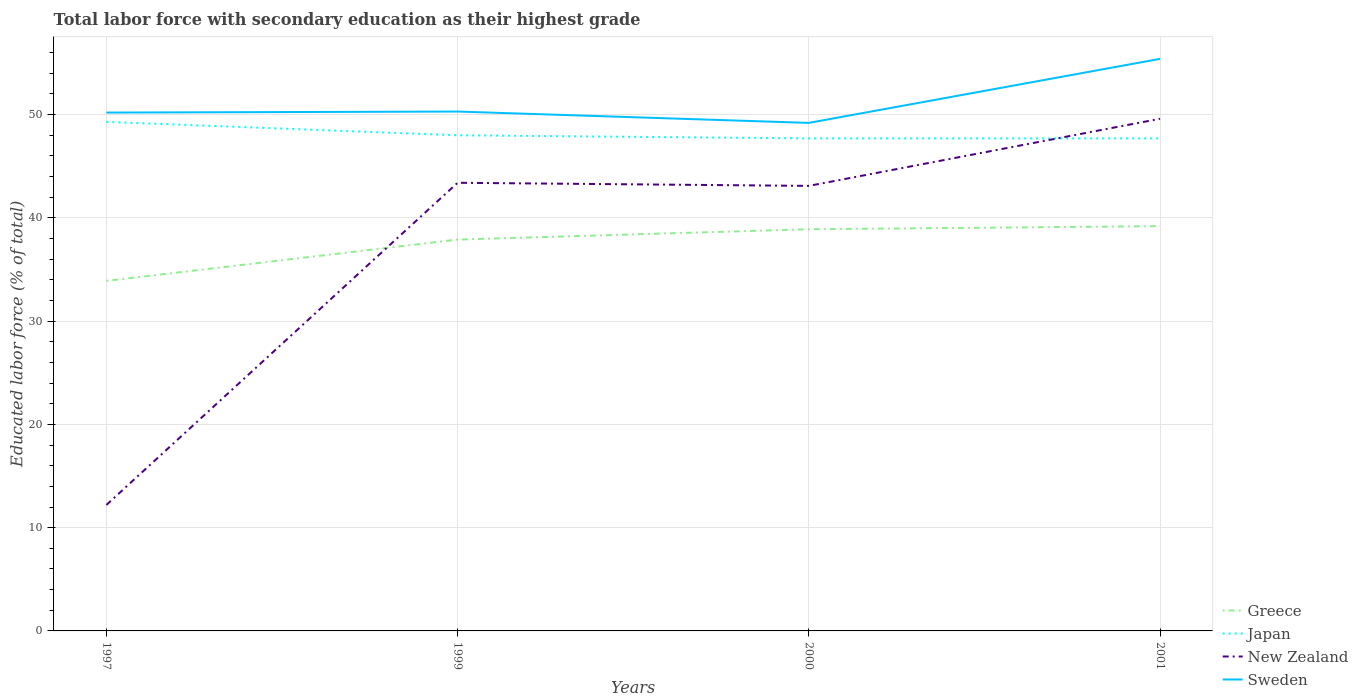How many different coloured lines are there?
Keep it short and to the point. 4. Does the line corresponding to Greece intersect with the line corresponding to Japan?
Offer a very short reply. No. Across all years, what is the maximum percentage of total labor force with primary education in Sweden?
Give a very brief answer. 49.2. In which year was the percentage of total labor force with primary education in Japan maximum?
Offer a very short reply. 2000. What is the total percentage of total labor force with primary education in New Zealand in the graph?
Your answer should be compact. 0.3. What is the difference between the highest and the second highest percentage of total labor force with primary education in Japan?
Keep it short and to the point. 1.6. What is the difference between the highest and the lowest percentage of total labor force with primary education in Japan?
Keep it short and to the point. 1. How many years are there in the graph?
Make the answer very short. 4. Where does the legend appear in the graph?
Your answer should be compact. Bottom right. How many legend labels are there?
Provide a short and direct response. 4. What is the title of the graph?
Your response must be concise. Total labor force with secondary education as their highest grade. What is the label or title of the Y-axis?
Keep it short and to the point. Educated labor force (% of total). What is the Educated labor force (% of total) of Greece in 1997?
Give a very brief answer. 33.9. What is the Educated labor force (% of total) of Japan in 1997?
Make the answer very short. 49.3. What is the Educated labor force (% of total) of New Zealand in 1997?
Give a very brief answer. 12.2. What is the Educated labor force (% of total) of Sweden in 1997?
Provide a short and direct response. 50.2. What is the Educated labor force (% of total) in Greece in 1999?
Offer a terse response. 37.9. What is the Educated labor force (% of total) in Japan in 1999?
Your answer should be compact. 48. What is the Educated labor force (% of total) in New Zealand in 1999?
Ensure brevity in your answer.  43.4. What is the Educated labor force (% of total) in Sweden in 1999?
Give a very brief answer. 50.3. What is the Educated labor force (% of total) in Greece in 2000?
Your response must be concise. 38.9. What is the Educated labor force (% of total) of Japan in 2000?
Your answer should be very brief. 47.7. What is the Educated labor force (% of total) in New Zealand in 2000?
Offer a very short reply. 43.1. What is the Educated labor force (% of total) of Sweden in 2000?
Offer a terse response. 49.2. What is the Educated labor force (% of total) in Greece in 2001?
Provide a succinct answer. 39.2. What is the Educated labor force (% of total) of Japan in 2001?
Give a very brief answer. 47.7. What is the Educated labor force (% of total) in New Zealand in 2001?
Keep it short and to the point. 49.6. What is the Educated labor force (% of total) of Sweden in 2001?
Ensure brevity in your answer.  55.4. Across all years, what is the maximum Educated labor force (% of total) in Greece?
Provide a short and direct response. 39.2. Across all years, what is the maximum Educated labor force (% of total) in Japan?
Make the answer very short. 49.3. Across all years, what is the maximum Educated labor force (% of total) of New Zealand?
Offer a terse response. 49.6. Across all years, what is the maximum Educated labor force (% of total) of Sweden?
Offer a terse response. 55.4. Across all years, what is the minimum Educated labor force (% of total) of Greece?
Keep it short and to the point. 33.9. Across all years, what is the minimum Educated labor force (% of total) of Japan?
Your answer should be very brief. 47.7. Across all years, what is the minimum Educated labor force (% of total) of New Zealand?
Your answer should be very brief. 12.2. Across all years, what is the minimum Educated labor force (% of total) of Sweden?
Provide a succinct answer. 49.2. What is the total Educated labor force (% of total) in Greece in the graph?
Provide a succinct answer. 149.9. What is the total Educated labor force (% of total) of Japan in the graph?
Your answer should be compact. 192.7. What is the total Educated labor force (% of total) of New Zealand in the graph?
Offer a terse response. 148.3. What is the total Educated labor force (% of total) in Sweden in the graph?
Offer a terse response. 205.1. What is the difference between the Educated labor force (% of total) in New Zealand in 1997 and that in 1999?
Make the answer very short. -31.2. What is the difference between the Educated labor force (% of total) in Sweden in 1997 and that in 1999?
Keep it short and to the point. -0.1. What is the difference between the Educated labor force (% of total) in Greece in 1997 and that in 2000?
Keep it short and to the point. -5. What is the difference between the Educated labor force (% of total) of New Zealand in 1997 and that in 2000?
Ensure brevity in your answer.  -30.9. What is the difference between the Educated labor force (% of total) of Sweden in 1997 and that in 2000?
Offer a very short reply. 1. What is the difference between the Educated labor force (% of total) of Greece in 1997 and that in 2001?
Provide a short and direct response. -5.3. What is the difference between the Educated labor force (% of total) of Japan in 1997 and that in 2001?
Offer a terse response. 1.6. What is the difference between the Educated labor force (% of total) in New Zealand in 1997 and that in 2001?
Make the answer very short. -37.4. What is the difference between the Educated labor force (% of total) of Sweden in 1997 and that in 2001?
Your response must be concise. -5.2. What is the difference between the Educated labor force (% of total) in Japan in 1999 and that in 2000?
Ensure brevity in your answer.  0.3. What is the difference between the Educated labor force (% of total) in Sweden in 1999 and that in 2000?
Give a very brief answer. 1.1. What is the difference between the Educated labor force (% of total) in Sweden in 1999 and that in 2001?
Provide a succinct answer. -5.1. What is the difference between the Educated labor force (% of total) of Japan in 2000 and that in 2001?
Keep it short and to the point. 0. What is the difference between the Educated labor force (% of total) of New Zealand in 2000 and that in 2001?
Give a very brief answer. -6.5. What is the difference between the Educated labor force (% of total) of Sweden in 2000 and that in 2001?
Ensure brevity in your answer.  -6.2. What is the difference between the Educated labor force (% of total) in Greece in 1997 and the Educated labor force (% of total) in Japan in 1999?
Keep it short and to the point. -14.1. What is the difference between the Educated labor force (% of total) of Greece in 1997 and the Educated labor force (% of total) of New Zealand in 1999?
Give a very brief answer. -9.5. What is the difference between the Educated labor force (% of total) of Greece in 1997 and the Educated labor force (% of total) of Sweden in 1999?
Provide a short and direct response. -16.4. What is the difference between the Educated labor force (% of total) of Japan in 1997 and the Educated labor force (% of total) of Sweden in 1999?
Provide a short and direct response. -1. What is the difference between the Educated labor force (% of total) in New Zealand in 1997 and the Educated labor force (% of total) in Sweden in 1999?
Your answer should be compact. -38.1. What is the difference between the Educated labor force (% of total) of Greece in 1997 and the Educated labor force (% of total) of Japan in 2000?
Ensure brevity in your answer.  -13.8. What is the difference between the Educated labor force (% of total) of Greece in 1997 and the Educated labor force (% of total) of Sweden in 2000?
Your answer should be compact. -15.3. What is the difference between the Educated labor force (% of total) in Japan in 1997 and the Educated labor force (% of total) in New Zealand in 2000?
Provide a succinct answer. 6.2. What is the difference between the Educated labor force (% of total) in New Zealand in 1997 and the Educated labor force (% of total) in Sweden in 2000?
Ensure brevity in your answer.  -37. What is the difference between the Educated labor force (% of total) of Greece in 1997 and the Educated labor force (% of total) of New Zealand in 2001?
Offer a very short reply. -15.7. What is the difference between the Educated labor force (% of total) in Greece in 1997 and the Educated labor force (% of total) in Sweden in 2001?
Provide a succinct answer. -21.5. What is the difference between the Educated labor force (% of total) of Japan in 1997 and the Educated labor force (% of total) of New Zealand in 2001?
Your response must be concise. -0.3. What is the difference between the Educated labor force (% of total) in New Zealand in 1997 and the Educated labor force (% of total) in Sweden in 2001?
Your answer should be very brief. -43.2. What is the difference between the Educated labor force (% of total) in Greece in 1999 and the Educated labor force (% of total) in Japan in 2000?
Your answer should be compact. -9.8. What is the difference between the Educated labor force (% of total) of New Zealand in 1999 and the Educated labor force (% of total) of Sweden in 2000?
Give a very brief answer. -5.8. What is the difference between the Educated labor force (% of total) in Greece in 1999 and the Educated labor force (% of total) in New Zealand in 2001?
Keep it short and to the point. -11.7. What is the difference between the Educated labor force (% of total) in Greece in 1999 and the Educated labor force (% of total) in Sweden in 2001?
Your answer should be compact. -17.5. What is the difference between the Educated labor force (% of total) in Japan in 1999 and the Educated labor force (% of total) in New Zealand in 2001?
Your answer should be compact. -1.6. What is the difference between the Educated labor force (% of total) of Japan in 1999 and the Educated labor force (% of total) of Sweden in 2001?
Give a very brief answer. -7.4. What is the difference between the Educated labor force (% of total) in New Zealand in 1999 and the Educated labor force (% of total) in Sweden in 2001?
Provide a short and direct response. -12. What is the difference between the Educated labor force (% of total) in Greece in 2000 and the Educated labor force (% of total) in Japan in 2001?
Offer a terse response. -8.8. What is the difference between the Educated labor force (% of total) in Greece in 2000 and the Educated labor force (% of total) in Sweden in 2001?
Your response must be concise. -16.5. What is the average Educated labor force (% of total) of Greece per year?
Keep it short and to the point. 37.48. What is the average Educated labor force (% of total) of Japan per year?
Keep it short and to the point. 48.17. What is the average Educated labor force (% of total) in New Zealand per year?
Your answer should be compact. 37.08. What is the average Educated labor force (% of total) in Sweden per year?
Keep it short and to the point. 51.27. In the year 1997, what is the difference between the Educated labor force (% of total) of Greece and Educated labor force (% of total) of Japan?
Ensure brevity in your answer.  -15.4. In the year 1997, what is the difference between the Educated labor force (% of total) of Greece and Educated labor force (% of total) of New Zealand?
Give a very brief answer. 21.7. In the year 1997, what is the difference between the Educated labor force (% of total) in Greece and Educated labor force (% of total) in Sweden?
Your answer should be compact. -16.3. In the year 1997, what is the difference between the Educated labor force (% of total) in Japan and Educated labor force (% of total) in New Zealand?
Offer a very short reply. 37.1. In the year 1997, what is the difference between the Educated labor force (% of total) in Japan and Educated labor force (% of total) in Sweden?
Offer a terse response. -0.9. In the year 1997, what is the difference between the Educated labor force (% of total) in New Zealand and Educated labor force (% of total) in Sweden?
Keep it short and to the point. -38. In the year 1999, what is the difference between the Educated labor force (% of total) of Japan and Educated labor force (% of total) of New Zealand?
Offer a terse response. 4.6. In the year 2000, what is the difference between the Educated labor force (% of total) of Greece and Educated labor force (% of total) of Japan?
Your answer should be very brief. -8.8. In the year 2000, what is the difference between the Educated labor force (% of total) of Greece and Educated labor force (% of total) of New Zealand?
Keep it short and to the point. -4.2. In the year 2000, what is the difference between the Educated labor force (% of total) in Greece and Educated labor force (% of total) in Sweden?
Your response must be concise. -10.3. In the year 2000, what is the difference between the Educated labor force (% of total) in Japan and Educated labor force (% of total) in Sweden?
Make the answer very short. -1.5. In the year 2000, what is the difference between the Educated labor force (% of total) in New Zealand and Educated labor force (% of total) in Sweden?
Your answer should be very brief. -6.1. In the year 2001, what is the difference between the Educated labor force (% of total) in Greece and Educated labor force (% of total) in Japan?
Provide a short and direct response. -8.5. In the year 2001, what is the difference between the Educated labor force (% of total) of Greece and Educated labor force (% of total) of Sweden?
Ensure brevity in your answer.  -16.2. In the year 2001, what is the difference between the Educated labor force (% of total) of New Zealand and Educated labor force (% of total) of Sweden?
Your answer should be compact. -5.8. What is the ratio of the Educated labor force (% of total) of Greece in 1997 to that in 1999?
Offer a terse response. 0.89. What is the ratio of the Educated labor force (% of total) in Japan in 1997 to that in 1999?
Ensure brevity in your answer.  1.03. What is the ratio of the Educated labor force (% of total) in New Zealand in 1997 to that in 1999?
Provide a short and direct response. 0.28. What is the ratio of the Educated labor force (% of total) of Greece in 1997 to that in 2000?
Provide a succinct answer. 0.87. What is the ratio of the Educated labor force (% of total) in Japan in 1997 to that in 2000?
Ensure brevity in your answer.  1.03. What is the ratio of the Educated labor force (% of total) of New Zealand in 1997 to that in 2000?
Your answer should be very brief. 0.28. What is the ratio of the Educated labor force (% of total) of Sweden in 1997 to that in 2000?
Offer a terse response. 1.02. What is the ratio of the Educated labor force (% of total) of Greece in 1997 to that in 2001?
Give a very brief answer. 0.86. What is the ratio of the Educated labor force (% of total) of Japan in 1997 to that in 2001?
Offer a terse response. 1.03. What is the ratio of the Educated labor force (% of total) of New Zealand in 1997 to that in 2001?
Offer a terse response. 0.25. What is the ratio of the Educated labor force (% of total) in Sweden in 1997 to that in 2001?
Ensure brevity in your answer.  0.91. What is the ratio of the Educated labor force (% of total) in Greece in 1999 to that in 2000?
Give a very brief answer. 0.97. What is the ratio of the Educated labor force (% of total) of Japan in 1999 to that in 2000?
Make the answer very short. 1.01. What is the ratio of the Educated labor force (% of total) in Sweden in 1999 to that in 2000?
Offer a very short reply. 1.02. What is the ratio of the Educated labor force (% of total) in Greece in 1999 to that in 2001?
Your answer should be very brief. 0.97. What is the ratio of the Educated labor force (% of total) of New Zealand in 1999 to that in 2001?
Make the answer very short. 0.88. What is the ratio of the Educated labor force (% of total) in Sweden in 1999 to that in 2001?
Give a very brief answer. 0.91. What is the ratio of the Educated labor force (% of total) in New Zealand in 2000 to that in 2001?
Your answer should be compact. 0.87. What is the ratio of the Educated labor force (% of total) of Sweden in 2000 to that in 2001?
Your answer should be compact. 0.89. What is the difference between the highest and the second highest Educated labor force (% of total) of Greece?
Provide a succinct answer. 0.3. What is the difference between the highest and the second highest Educated labor force (% of total) of Japan?
Your response must be concise. 1.3. What is the difference between the highest and the second highest Educated labor force (% of total) of New Zealand?
Provide a succinct answer. 6.2. What is the difference between the highest and the lowest Educated labor force (% of total) of Japan?
Provide a succinct answer. 1.6. What is the difference between the highest and the lowest Educated labor force (% of total) of New Zealand?
Your answer should be compact. 37.4. 